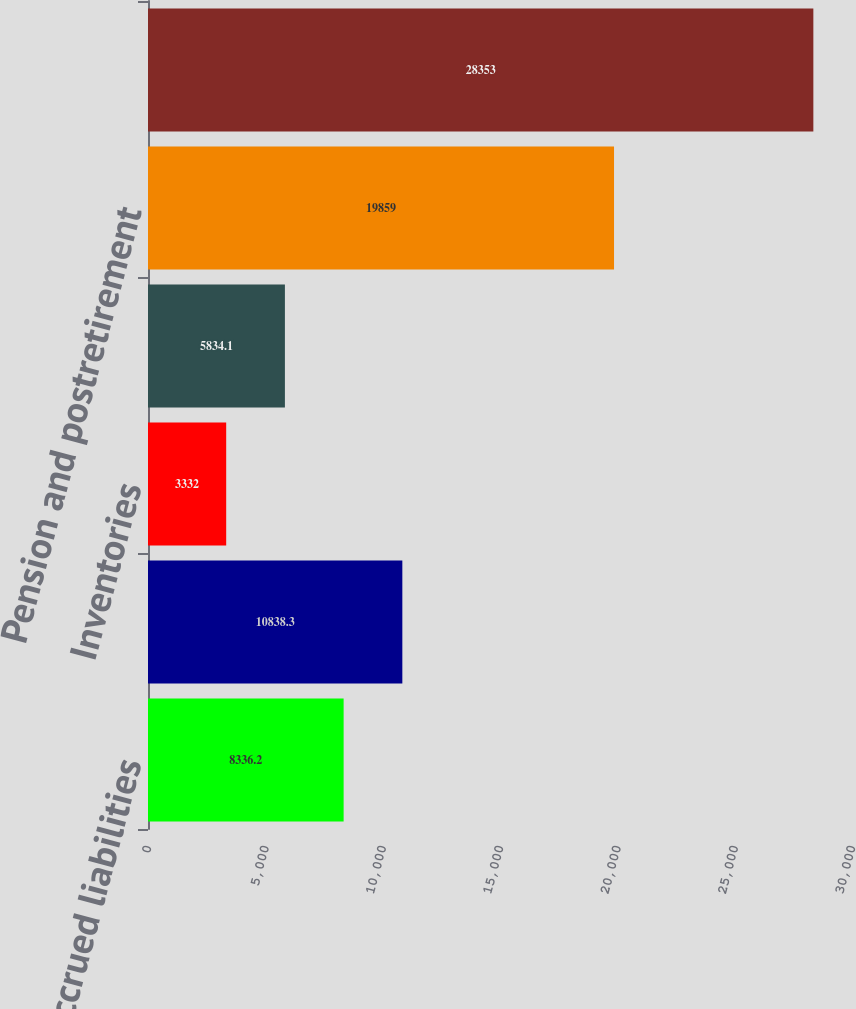<chart> <loc_0><loc_0><loc_500><loc_500><bar_chart><fcel>Accrued liabilities<fcel>Employee benefits and<fcel>Inventories<fcel>Stock options and restricted<fcel>Pension and postretirement<fcel>Investment in joint venture<nl><fcel>8336.2<fcel>10838.3<fcel>3332<fcel>5834.1<fcel>19859<fcel>28353<nl></chart> 